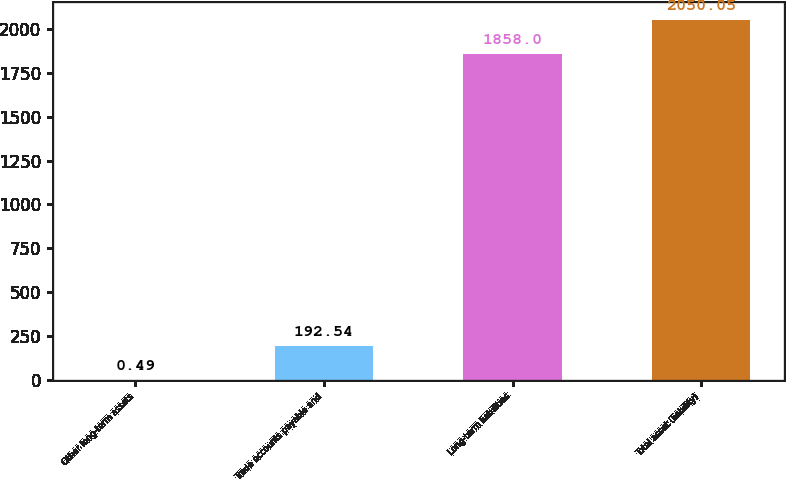<chart> <loc_0><loc_0><loc_500><loc_500><bar_chart><fcel>Other long-term assets<fcel>Trade accounts payable and<fcel>Long-term liabilities<fcel>Total asset (liability)<nl><fcel>0.49<fcel>192.54<fcel>1858<fcel>2050.05<nl></chart> 